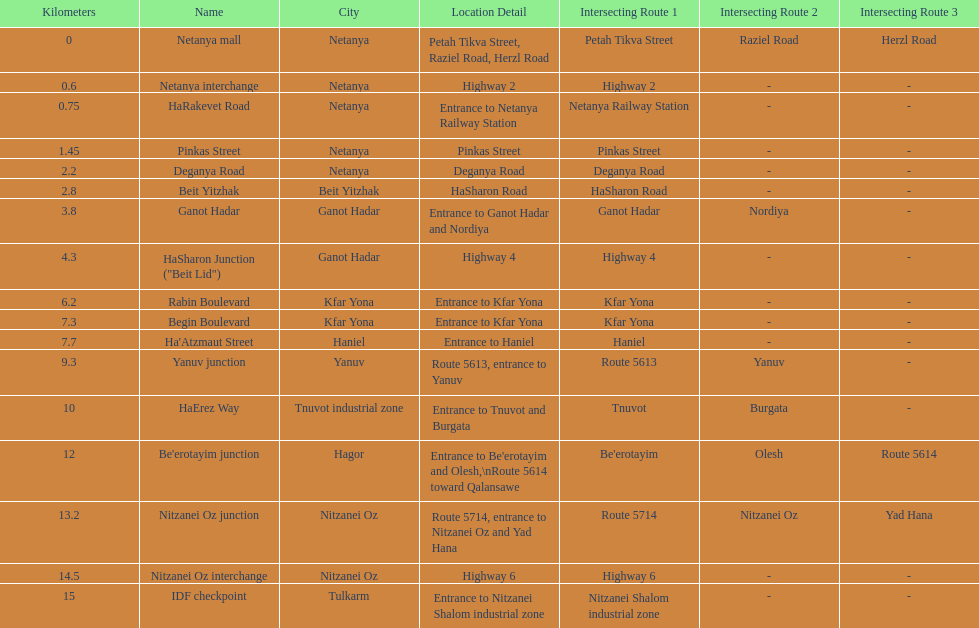How many sections intersect highway 2? 1. 